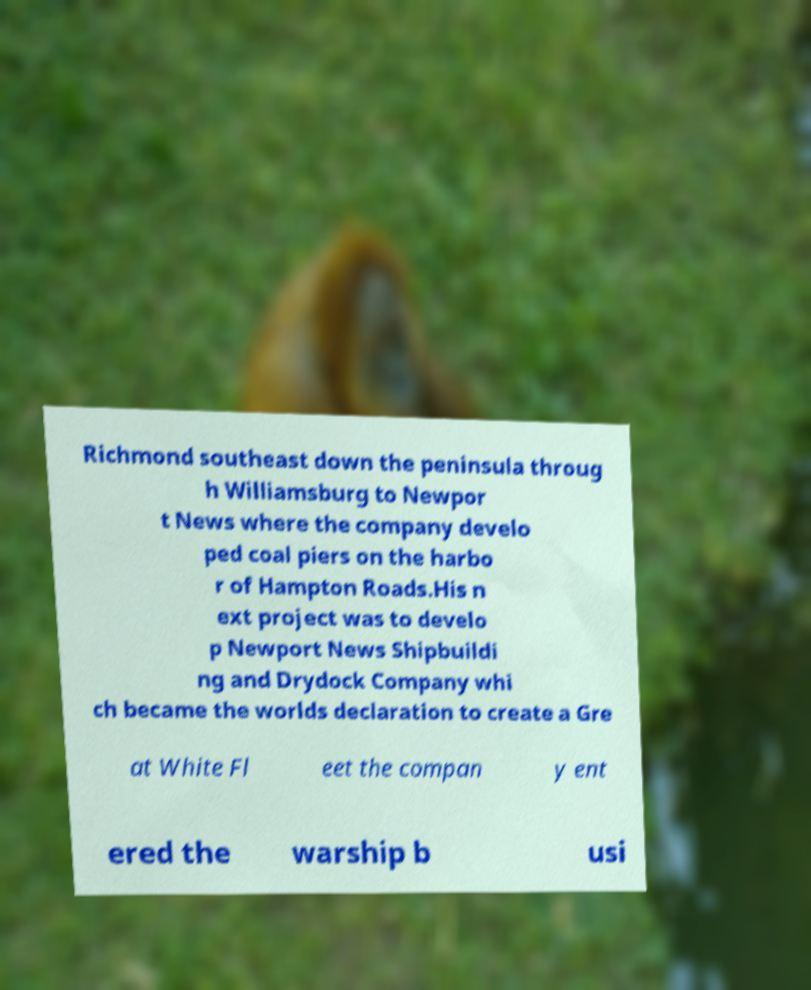Could you extract and type out the text from this image? Richmond southeast down the peninsula throug h Williamsburg to Newpor t News where the company develo ped coal piers on the harbo r of Hampton Roads.His n ext project was to develo p Newport News Shipbuildi ng and Drydock Company whi ch became the worlds declaration to create a Gre at White Fl eet the compan y ent ered the warship b usi 